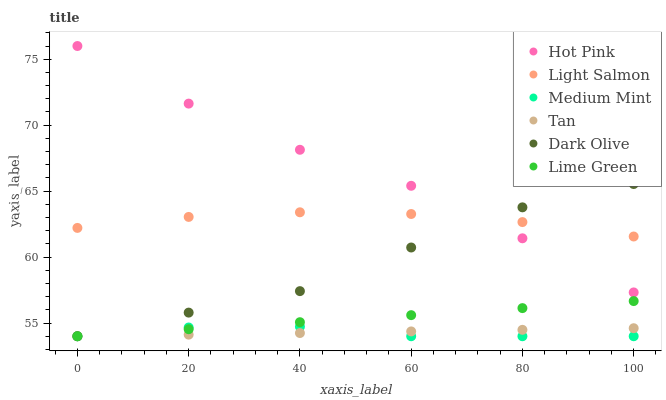Does Medium Mint have the minimum area under the curve?
Answer yes or no. Yes. Does Hot Pink have the maximum area under the curve?
Answer yes or no. Yes. Does Light Salmon have the minimum area under the curve?
Answer yes or no. No. Does Light Salmon have the maximum area under the curve?
Answer yes or no. No. Is Tan the smoothest?
Answer yes or no. Yes. Is Dark Olive the roughest?
Answer yes or no. Yes. Is Light Salmon the smoothest?
Answer yes or no. No. Is Light Salmon the roughest?
Answer yes or no. No. Does Medium Mint have the lowest value?
Answer yes or no. Yes. Does Light Salmon have the lowest value?
Answer yes or no. No. Does Hot Pink have the highest value?
Answer yes or no. Yes. Does Light Salmon have the highest value?
Answer yes or no. No. Is Medium Mint less than Hot Pink?
Answer yes or no. Yes. Is Hot Pink greater than Medium Mint?
Answer yes or no. Yes. Does Light Salmon intersect Hot Pink?
Answer yes or no. Yes. Is Light Salmon less than Hot Pink?
Answer yes or no. No. Is Light Salmon greater than Hot Pink?
Answer yes or no. No. Does Medium Mint intersect Hot Pink?
Answer yes or no. No. 